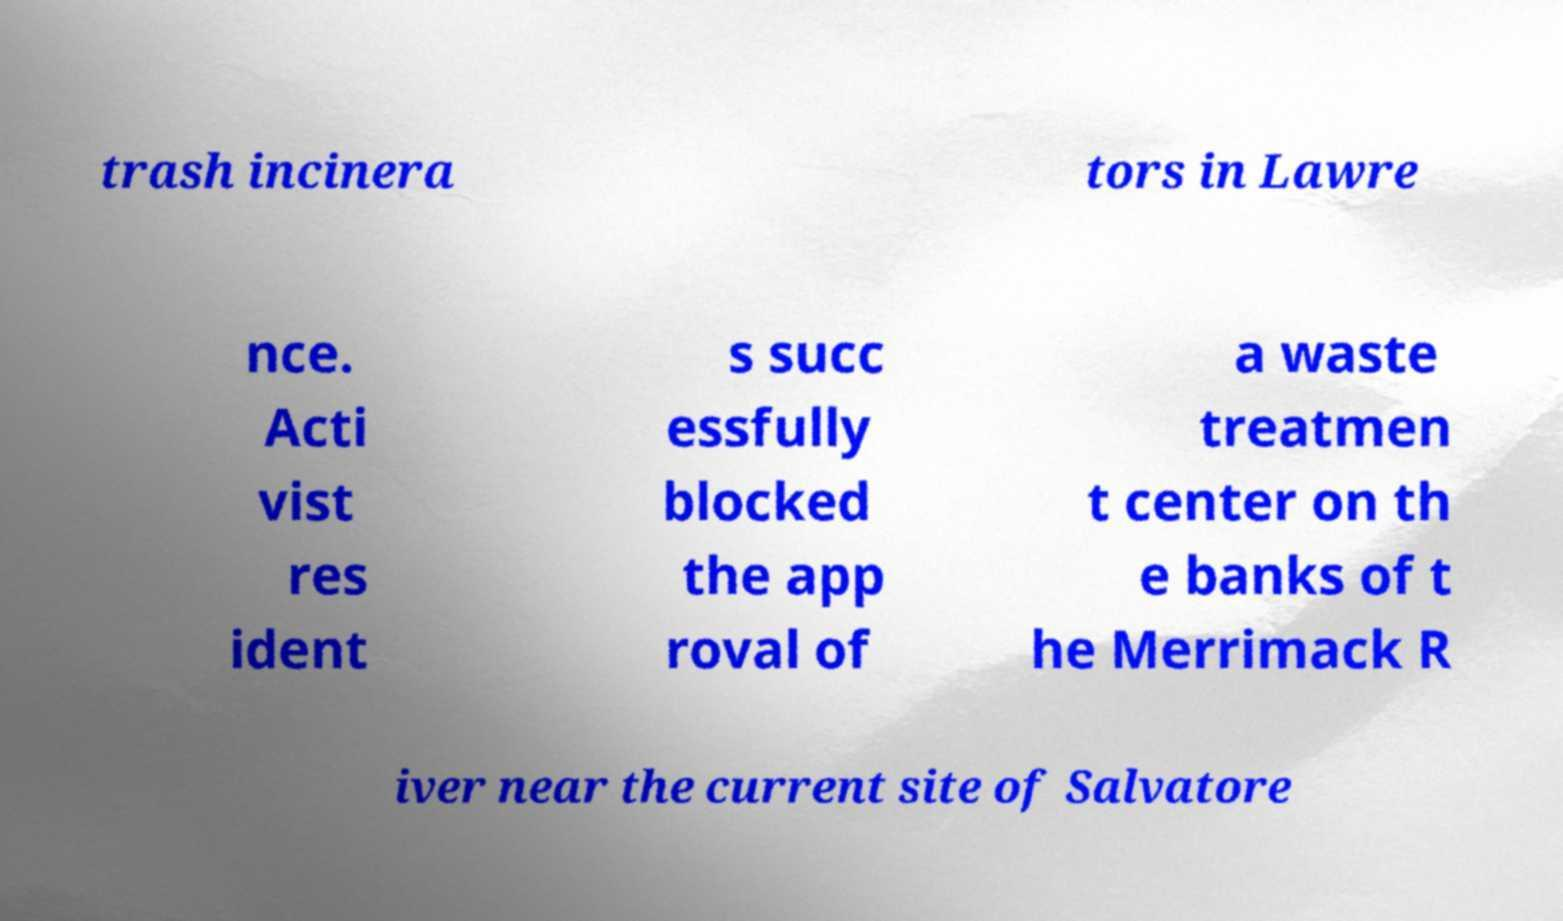Could you assist in decoding the text presented in this image and type it out clearly? trash incinera tors in Lawre nce. Acti vist res ident s succ essfully blocked the app roval of a waste treatmen t center on th e banks of t he Merrimack R iver near the current site of Salvatore 